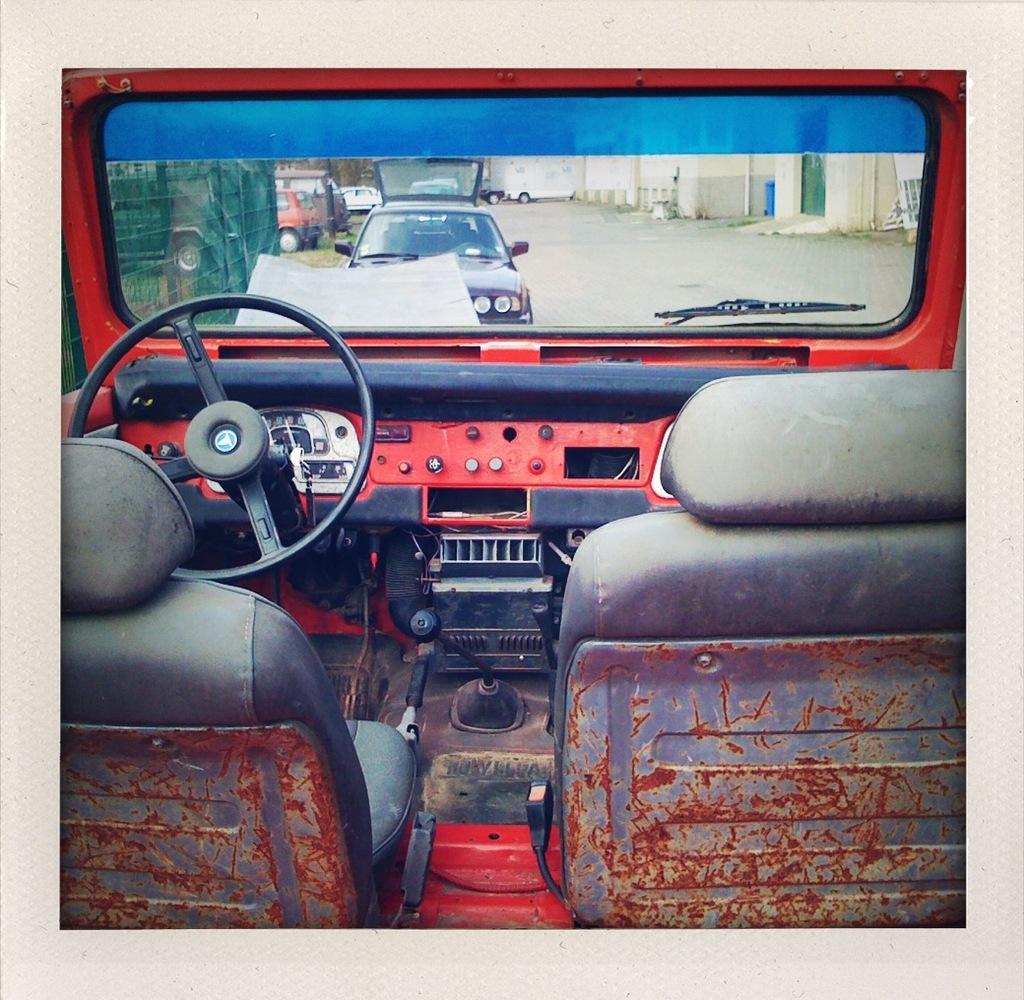Describe this image in one or two sentences. In this image we can see photograph on a album page. In the photo we can see a vehicle and through its windshield we can see vehicles on the road, buildings, door, pipes on the wall and objects. 